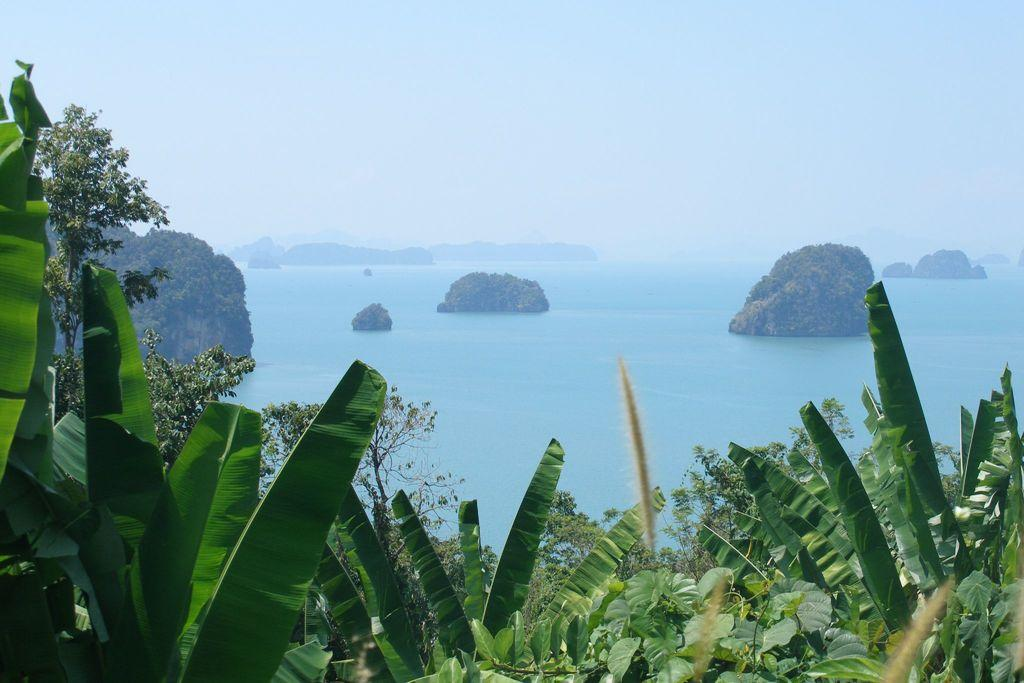What type of vegetation is at the bottom of the image? There are trees at the bottom of the image. What natural feature is in the center of the image? There is a sea in the center of the image. What can be seen in the background of the image? There is a hill and the sky visible in the background. What color is the crayon used by the writer in the image? There is no writer or crayon present in the image. What type of stone is visible on the hill in the image? There is no stone visible on the hill in the image; only the hill and the sky are present. 